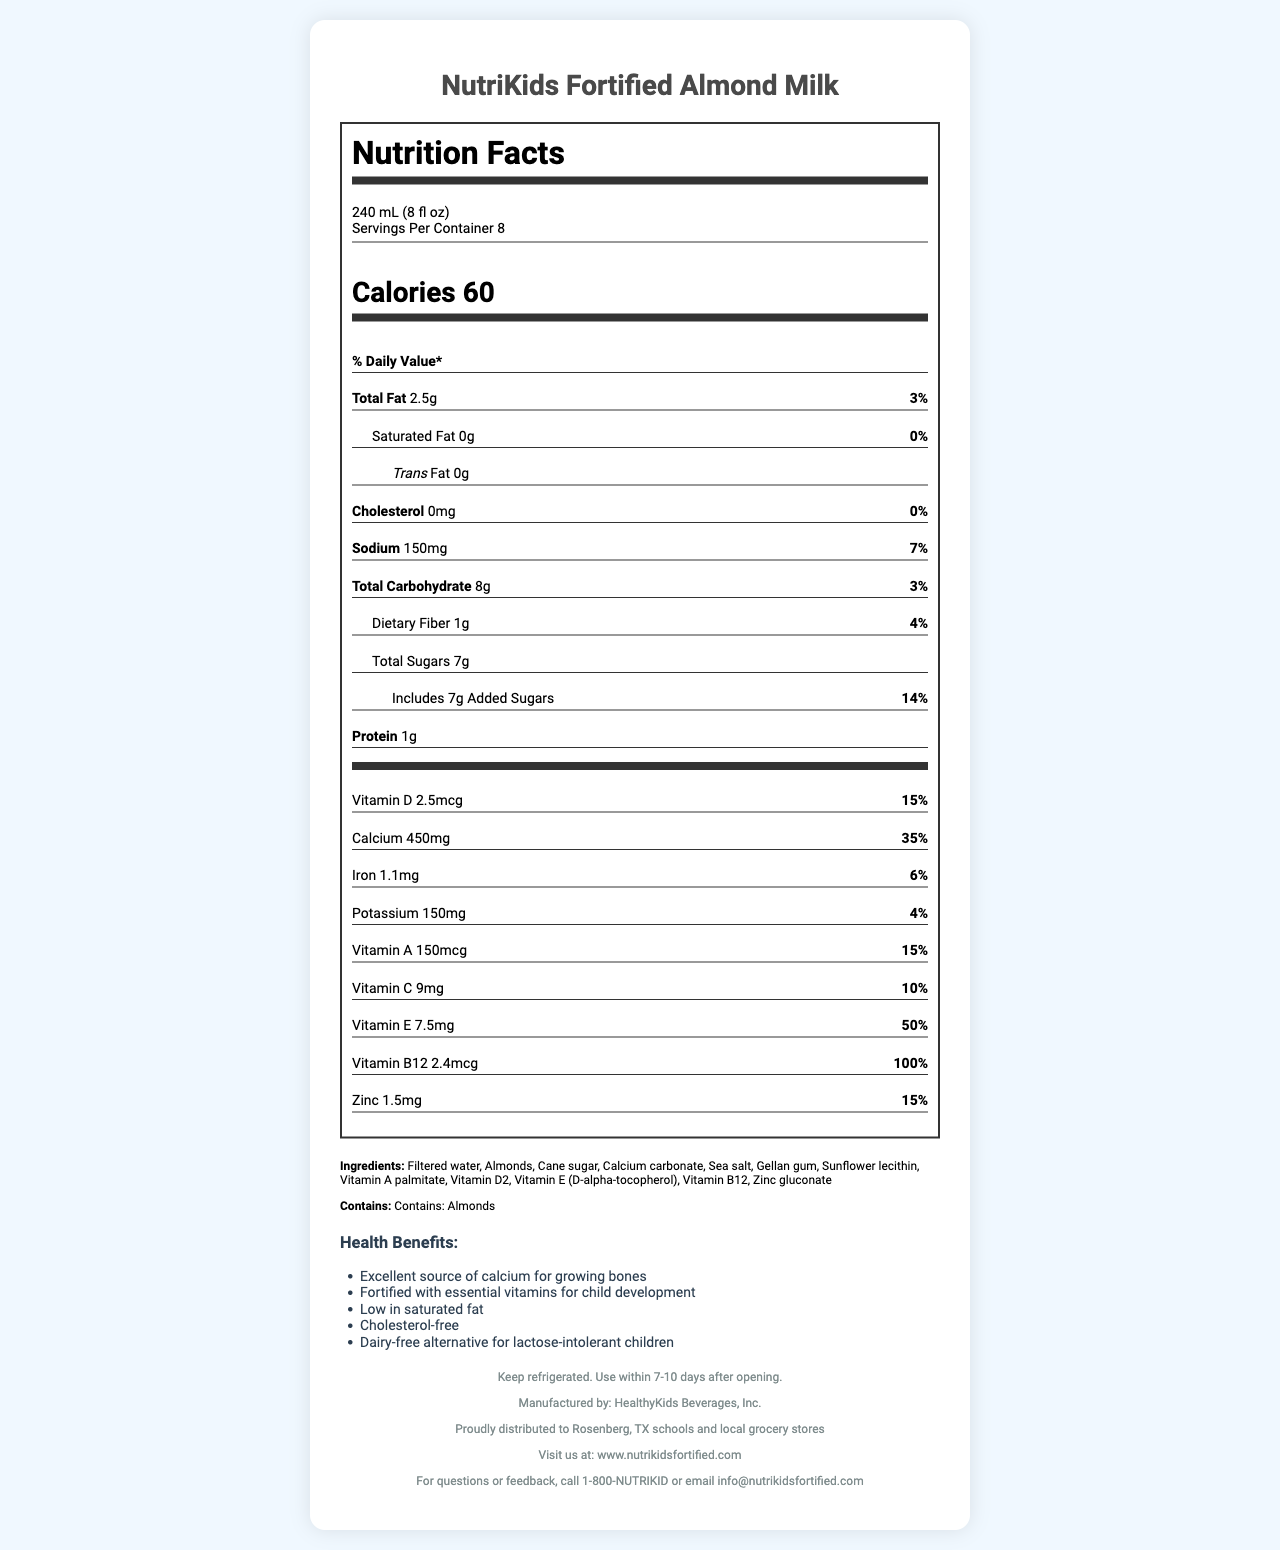what is the serving size for NutriKids Fortified Almond Milk? The serving size information is clearly listed near the top of the nutrition facts box.
Answer: 240 mL (8 fl oz) how many calories are in one serving of NutriKids Fortified Almond Milk? The calorie content is prominently displayed in a large font in the nutrition facts box.
Answer: 60 what is the total fat content per serving? The total fat amount is listed in the nutrition facts section under Total Fat.
Answer: 2.5g does this product contain any cholesterol? The document states "Cholesterol 0mg" with a daily value of 0% indicating there is no cholesterol in the product.
Answer: No how much dietary fiber is in one serving? The amount of dietary fiber is provided in the nutrition facts under Dietary Fiber.
Answer: 1g which of the following vitamins is present in the highest daily value percentage per serving? A. Vitamin D B. Vitamin A C. Vitamin B12 D. Vitamin C Vitamin B12 has the highest daily value percentage at 100%, compared to the other vitamins listed.
Answer: C. Vitamin B12 what ingredient is listed first in the ingredients section? A. Almonds B. Filtered water C. Cane sugar D. Calcium carbonate Ingredients are commonly listed in order of quantity, and the first ingredient listed is Filtered water.
Answer: B. Filtered water is NutriKids Fortified Almond Milk dairy-free? One of the health claims states that it is a "Dairy-free alternative for lactose-intolerant children."
Answer: Yes summarize the main idea of the document. The document includes nutrition information, ingredient list, allergen info, health claims, storage instructions, manufacturer details, and contact information.
Answer: The document provides detailed nutrition facts and ingredient information for NutriKids Fortified Almond Milk, emphasizing its health benefits for children such as being low in saturated fat, cholesterol-free, and fortified with essential vitamins like calcium, vitamin D, and vitamin B12. how much potassium does one serving contain? The nutrition facts list Potassium content as 150mg per serving with a daily value of 4%.
Answer: 150mg what is the daily value percentage of calcium in one serving? The document states calcium content and its daily value percentage in the nutrition facts section, with calcium being 450mg and 35% daily value.
Answer: 35% does the product contain any artificial ingredients? The document does not specify whether the listed ingredients are natural or artificial.
Answer: Cannot be determined what company manufactures NutriKids Fortified Almond Milk? The footer of the document states that the product is manufactured by HealthyKids Beverages, Inc.
Answer: HealthyKids Beverages, Inc. 